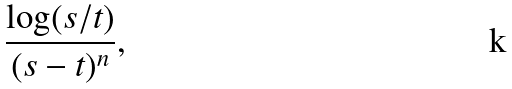<formula> <loc_0><loc_0><loc_500><loc_500>\frac { \log ( s / t ) } { ( s - t ) ^ { n } } ,</formula> 